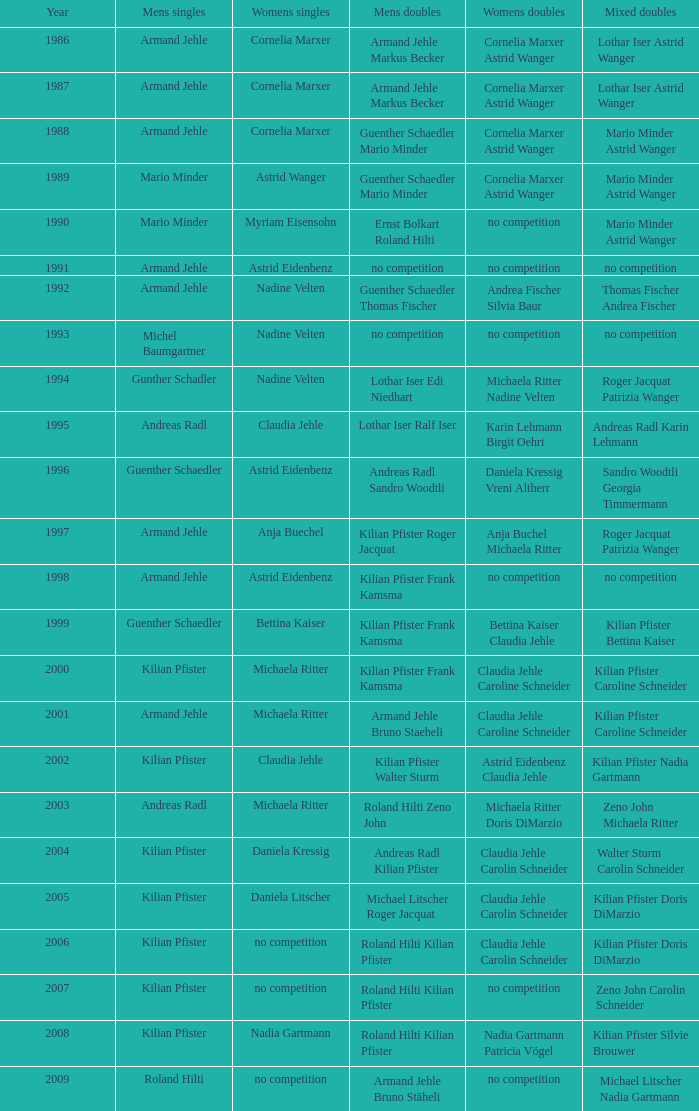In 2004, where the womens singles is daniela kressig who is the mens singles Kilian Pfister. 